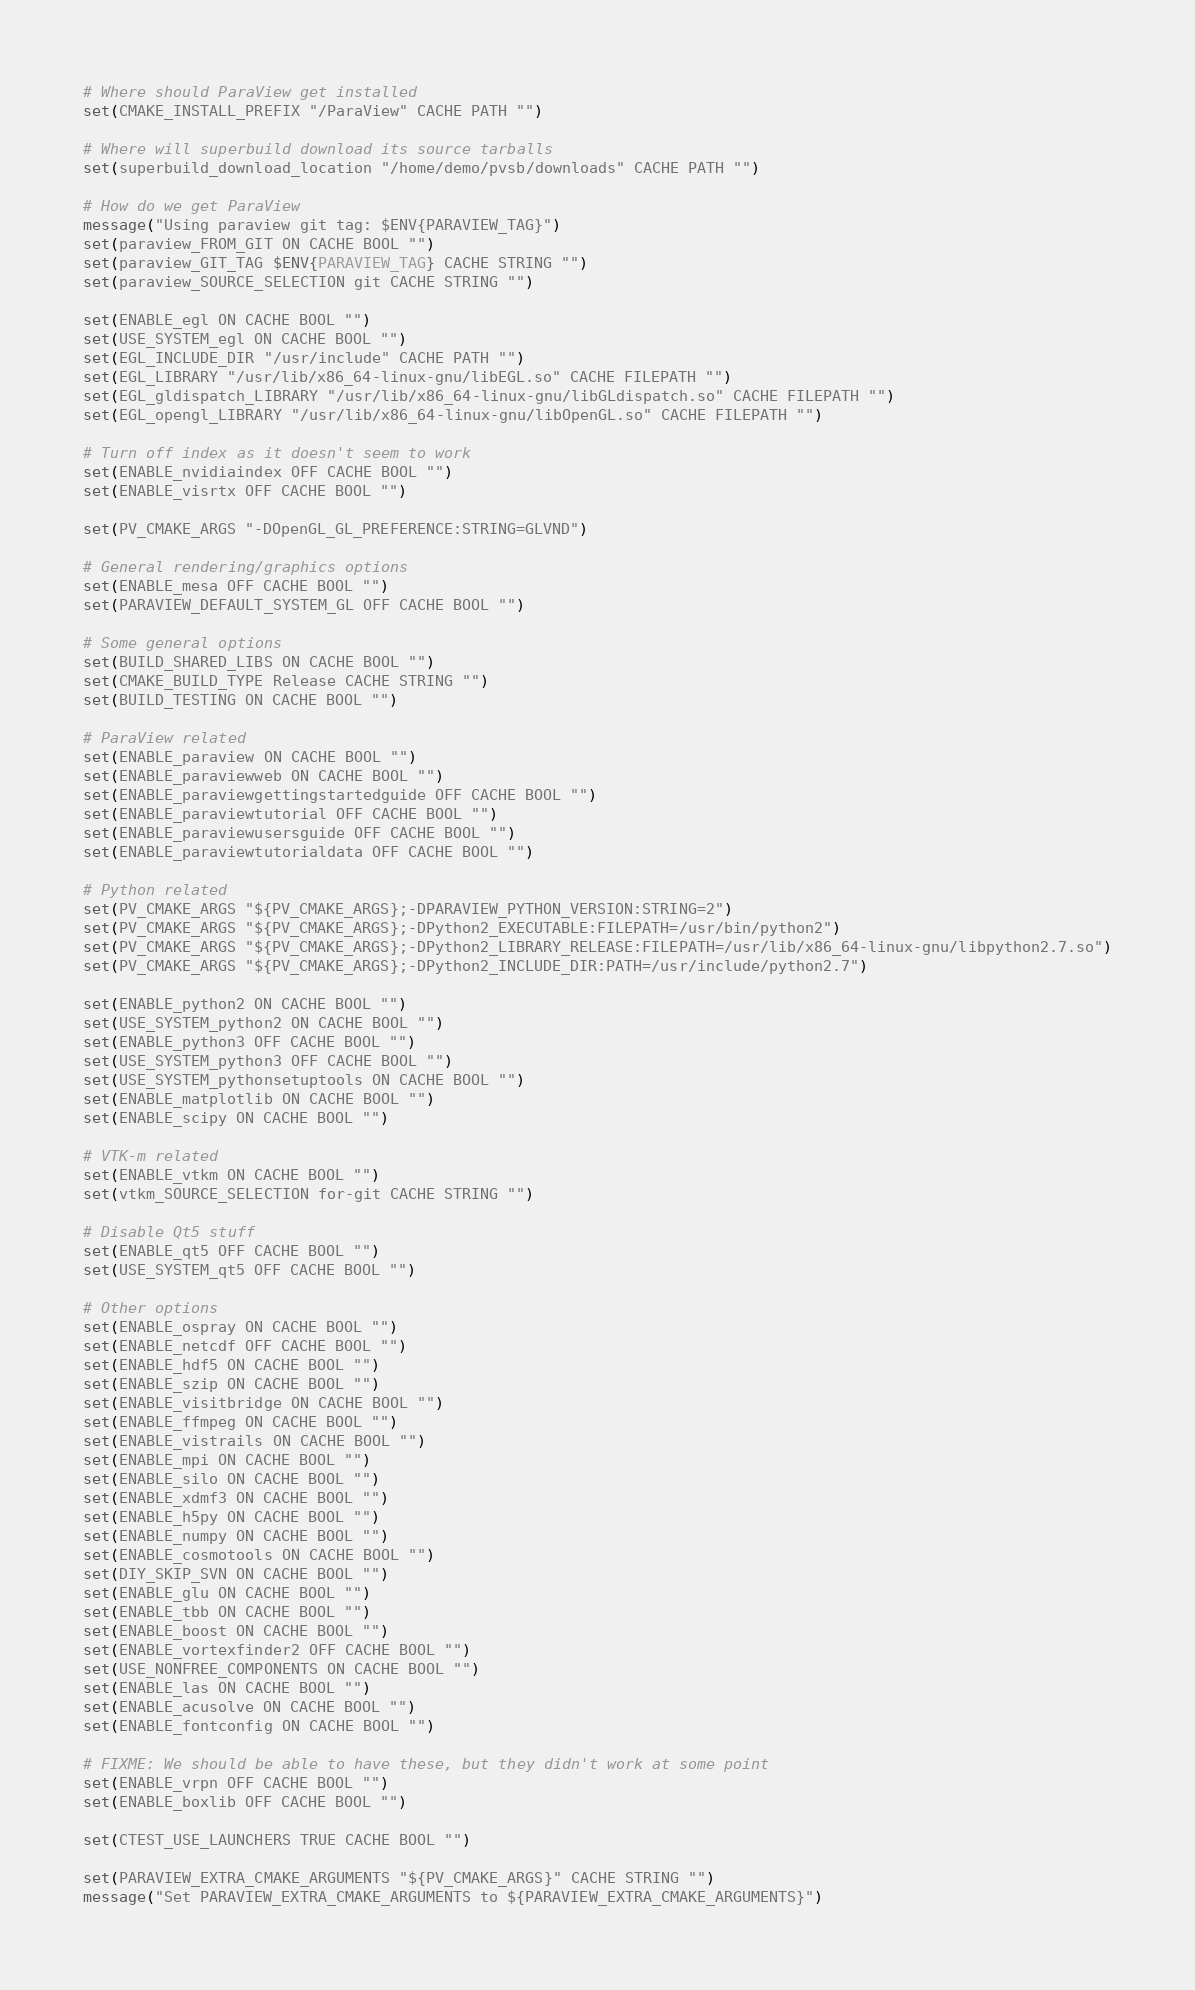Convert code to text. <code><loc_0><loc_0><loc_500><loc_500><_CMake_>
# Where should ParaView get installed
set(CMAKE_INSTALL_PREFIX "/ParaView" CACHE PATH "")

# Where will superbuild download its source tarballs
set(superbuild_download_location "/home/demo/pvsb/downloads" CACHE PATH "")

# How do we get ParaView
message("Using paraview git tag: $ENV{PARAVIEW_TAG}")
set(paraview_FROM_GIT ON CACHE BOOL "")
set(paraview_GIT_TAG $ENV{PARAVIEW_TAG} CACHE STRING "")
set(paraview_SOURCE_SELECTION git CACHE STRING "")

set(ENABLE_egl ON CACHE BOOL "")
set(USE_SYSTEM_egl ON CACHE BOOL "")
set(EGL_INCLUDE_DIR "/usr/include" CACHE PATH "")
set(EGL_LIBRARY "/usr/lib/x86_64-linux-gnu/libEGL.so" CACHE FILEPATH "")
set(EGL_gldispatch_LIBRARY "/usr/lib/x86_64-linux-gnu/libGLdispatch.so" CACHE FILEPATH "")
set(EGL_opengl_LIBRARY "/usr/lib/x86_64-linux-gnu/libOpenGL.so" CACHE FILEPATH "")

# Turn off index as it doesn't seem to work
set(ENABLE_nvidiaindex OFF CACHE BOOL "")
set(ENABLE_visrtx OFF CACHE BOOL "")

set(PV_CMAKE_ARGS "-DOpenGL_GL_PREFERENCE:STRING=GLVND")

# General rendering/graphics options
set(ENABLE_mesa OFF CACHE BOOL "")
set(PARAVIEW_DEFAULT_SYSTEM_GL OFF CACHE BOOL "")

# Some general options
set(BUILD_SHARED_LIBS ON CACHE BOOL "")
set(CMAKE_BUILD_TYPE Release CACHE STRING "")
set(BUILD_TESTING ON CACHE BOOL "")

# ParaView related
set(ENABLE_paraview ON CACHE BOOL "")
set(ENABLE_paraviewweb ON CACHE BOOL "")
set(ENABLE_paraviewgettingstartedguide OFF CACHE BOOL "")
set(ENABLE_paraviewtutorial OFF CACHE BOOL "")
set(ENABLE_paraviewusersguide OFF CACHE BOOL "")
set(ENABLE_paraviewtutorialdata OFF CACHE BOOL "")

# Python related
set(PV_CMAKE_ARGS "${PV_CMAKE_ARGS};-DPARAVIEW_PYTHON_VERSION:STRING=2")
set(PV_CMAKE_ARGS "${PV_CMAKE_ARGS};-DPython2_EXECUTABLE:FILEPATH=/usr/bin/python2")
set(PV_CMAKE_ARGS "${PV_CMAKE_ARGS};-DPython2_LIBRARY_RELEASE:FILEPATH=/usr/lib/x86_64-linux-gnu/libpython2.7.so")
set(PV_CMAKE_ARGS "${PV_CMAKE_ARGS};-DPython2_INCLUDE_DIR:PATH=/usr/include/python2.7")

set(ENABLE_python2 ON CACHE BOOL "")
set(USE_SYSTEM_python2 ON CACHE BOOL "")
set(ENABLE_python3 OFF CACHE BOOL "")
set(USE_SYSTEM_python3 OFF CACHE BOOL "")
set(USE_SYSTEM_pythonsetuptools ON CACHE BOOL "")
set(ENABLE_matplotlib ON CACHE BOOL "")
set(ENABLE_scipy ON CACHE BOOL "")

# VTK-m related
set(ENABLE_vtkm ON CACHE BOOL "")
set(vtkm_SOURCE_SELECTION for-git CACHE STRING "")

# Disable Qt5 stuff
set(ENABLE_qt5 OFF CACHE BOOL "")
set(USE_SYSTEM_qt5 OFF CACHE BOOL "")

# Other options
set(ENABLE_ospray ON CACHE BOOL "")
set(ENABLE_netcdf OFF CACHE BOOL "")
set(ENABLE_hdf5 ON CACHE BOOL "")
set(ENABLE_szip ON CACHE BOOL "")
set(ENABLE_visitbridge ON CACHE BOOL "")
set(ENABLE_ffmpeg ON CACHE BOOL "")
set(ENABLE_vistrails ON CACHE BOOL "")
set(ENABLE_mpi ON CACHE BOOL "")
set(ENABLE_silo ON CACHE BOOL "")
set(ENABLE_xdmf3 ON CACHE BOOL "")
set(ENABLE_h5py ON CACHE BOOL "")
set(ENABLE_numpy ON CACHE BOOL "")
set(ENABLE_cosmotools ON CACHE BOOL "")
set(DIY_SKIP_SVN ON CACHE BOOL "")
set(ENABLE_glu ON CACHE BOOL "")
set(ENABLE_tbb ON CACHE BOOL "")
set(ENABLE_boost ON CACHE BOOL "")
set(ENABLE_vortexfinder2 OFF CACHE BOOL "")
set(USE_NONFREE_COMPONENTS ON CACHE BOOL "")
set(ENABLE_las ON CACHE BOOL "")
set(ENABLE_acusolve ON CACHE BOOL "")
set(ENABLE_fontconfig ON CACHE BOOL "")

# FIXME: We should be able to have these, but they didn't work at some point
set(ENABLE_vrpn OFF CACHE BOOL "")
set(ENABLE_boxlib OFF CACHE BOOL "")

set(CTEST_USE_LAUNCHERS TRUE CACHE BOOL "")

set(PARAVIEW_EXTRA_CMAKE_ARGUMENTS "${PV_CMAKE_ARGS}" CACHE STRING "")
message("Set PARAVIEW_EXTRA_CMAKE_ARGUMENTS to ${PARAVIEW_EXTRA_CMAKE_ARGUMENTS}")
</code> 